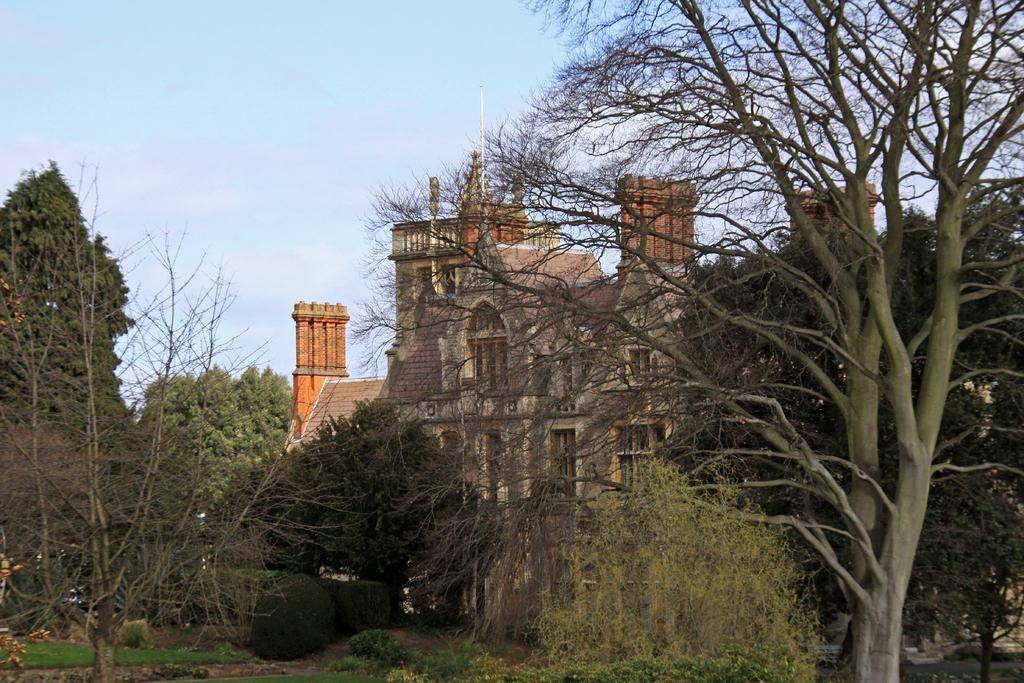What type of vegetation can be seen in the image? There are plants and trees in the image. Are there any structures visible in the image? Yes, there are buildings with windows in the image. What can be seen in the background of the image? The sky is visible in the background of the image. How many rabbits can be seen playing with a leaf in the image? There are no rabbits or leaves present in the image; it features plants, trees, buildings, and the sky. What type of woolly animal is grazing near the buildings in the image? There are no woolly animals, such as sheep, present in the image. 